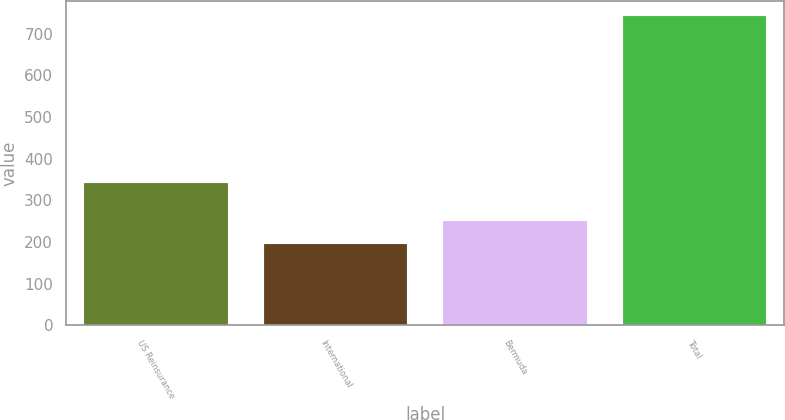<chart> <loc_0><loc_0><loc_500><loc_500><bar_chart><fcel>US Reinsurance<fcel>International<fcel>Bermuda<fcel>Total<nl><fcel>340.4<fcel>195.2<fcel>249.93<fcel>742.5<nl></chart> 